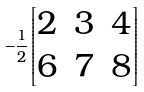<formula> <loc_0><loc_0><loc_500><loc_500>- \frac { 1 } { 2 } \begin{bmatrix} 2 & 3 & 4 \\ 6 & 7 & 8 \end{bmatrix}</formula> 